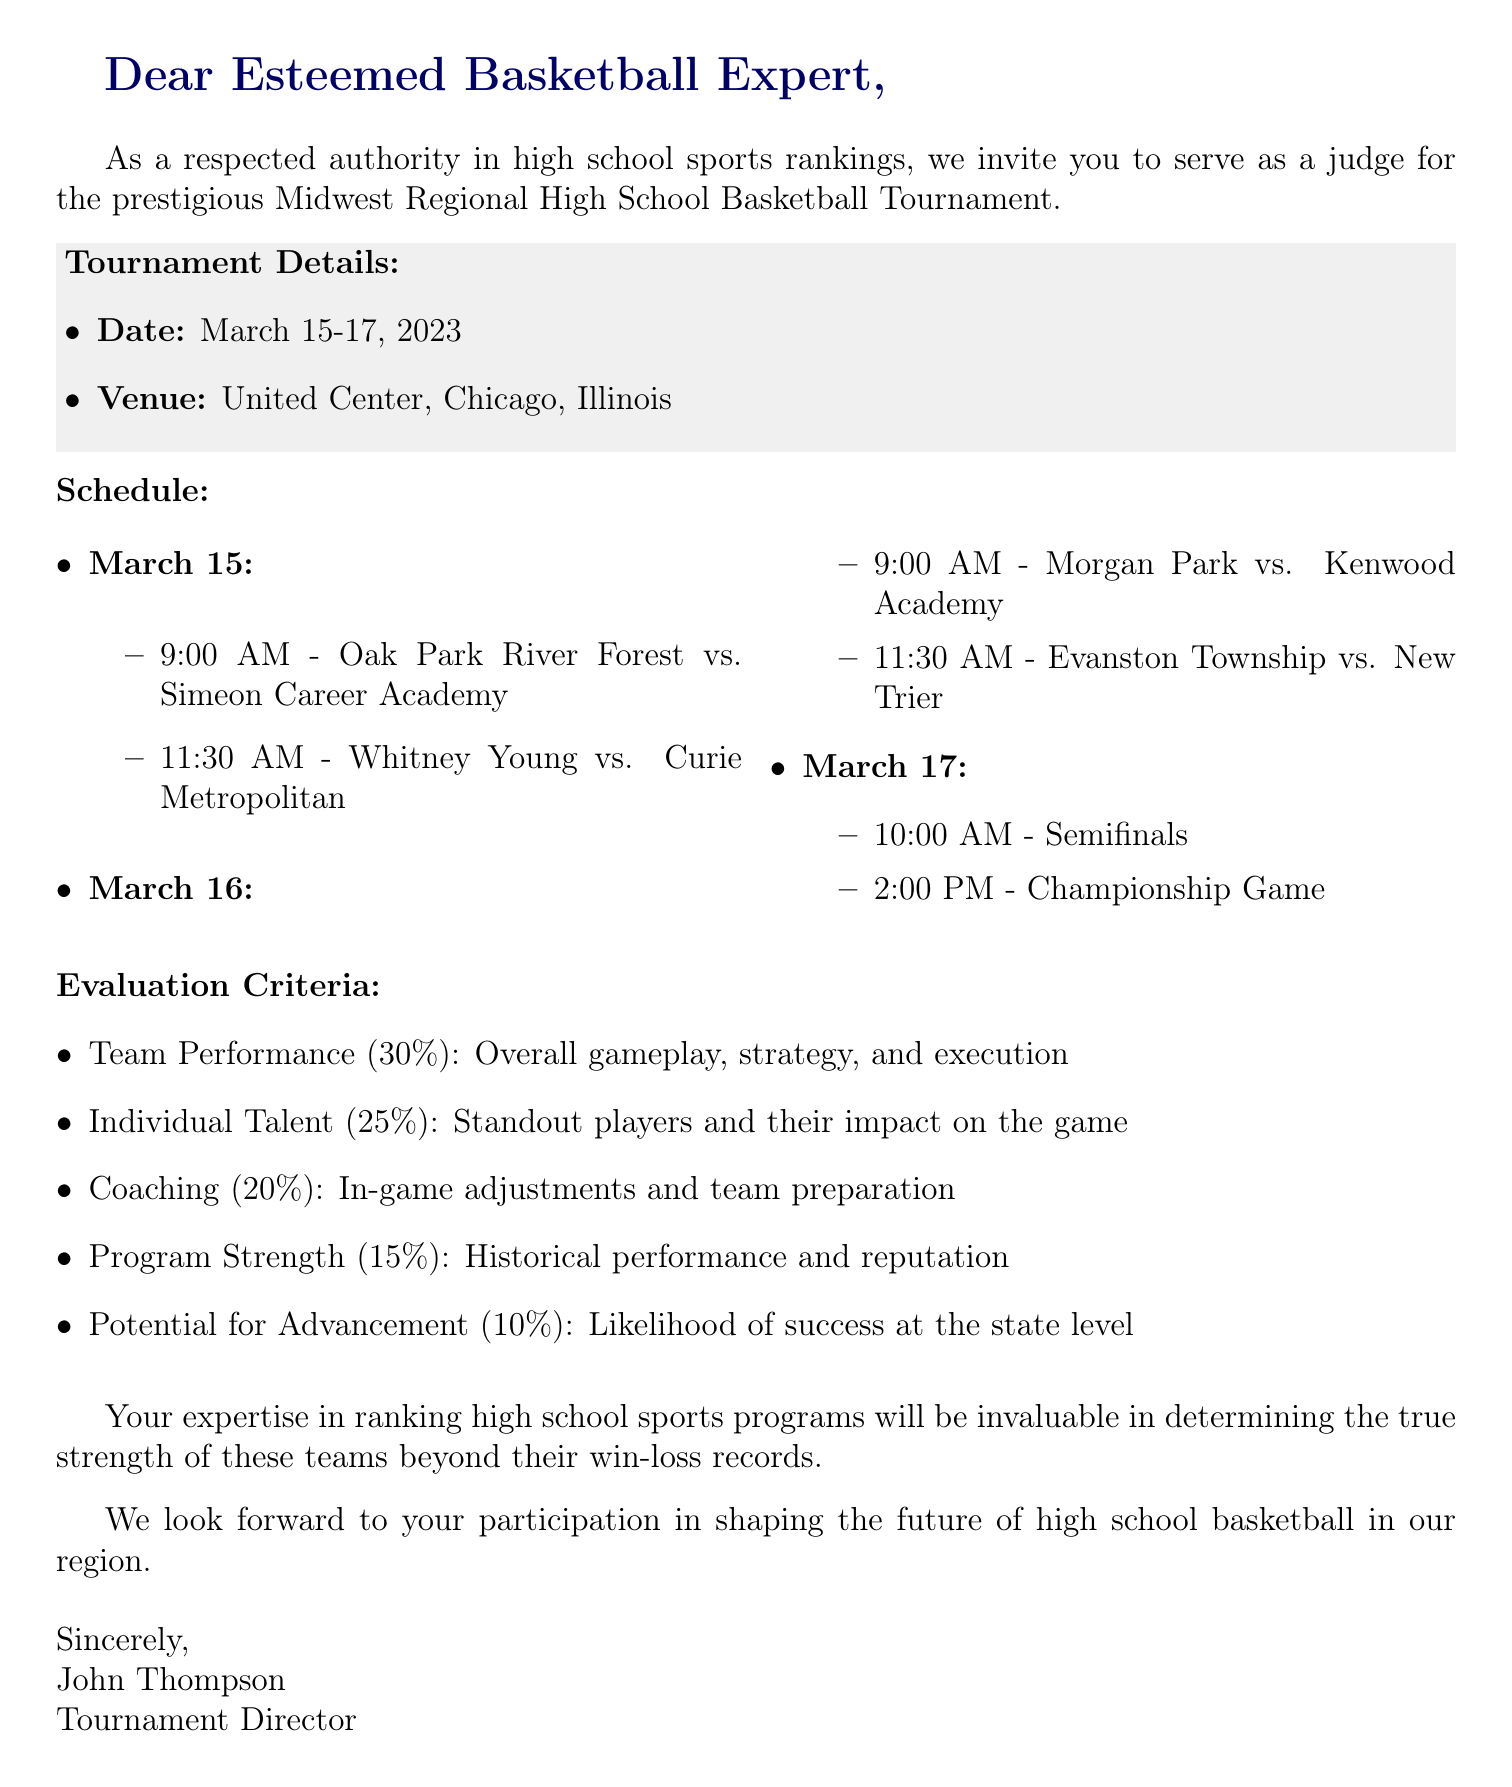What is the name of the tournament? The tournament name is explicitly stated in the introduction and the header.
Answer: 2023 Midwest Regional High School Basketball Tournament What are the dates of the tournament? The dates are clearly mentioned in the tournament details section.
Answer: March 15-17, 2023 What is the venue of the tournament? The venue is listed under the tournament details.
Answer: United Center, Chicago, Illinois How many games are scheduled on March 15? The schedule lists the games for each day, and on March 15, there are two games.
Answer: 2 What percentage of the evaluation criteria is assigned to Team Performance? The evaluation criteria specifies the percentage for each category including Team Performance.
Answer: 30% What are the start times for the semifinals on March 17? The schedule indicates the specific times for the semifinals.
Answer: 10:00 AM Who is the tournament director? The signature at the end of the document reveals the tournament director's name.
Answer: John Thompson What is evaluated as the lowest percentage criteria? The evaluation criteria lists all categories and their respective percentages, the lowest being Potential for Advancement.
Answer: Potential for Advancement (10%) Why is the recipient's expertise important according to the document? The introduction explains the recipient's role and the importance of their expertise in rankings beyond win-loss records.
Answer: To determine the true strength of these teams beyond their win-loss records 